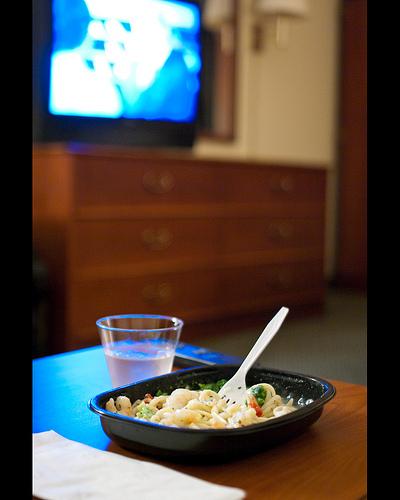What kind of utensil is the diner using?
Give a very brief answer. Fork. Is that salad on the plate?
Be succinct. No. Is the television on?
Be succinct. Yes. What is the dish made out of?
Be succinct. Plastic. 